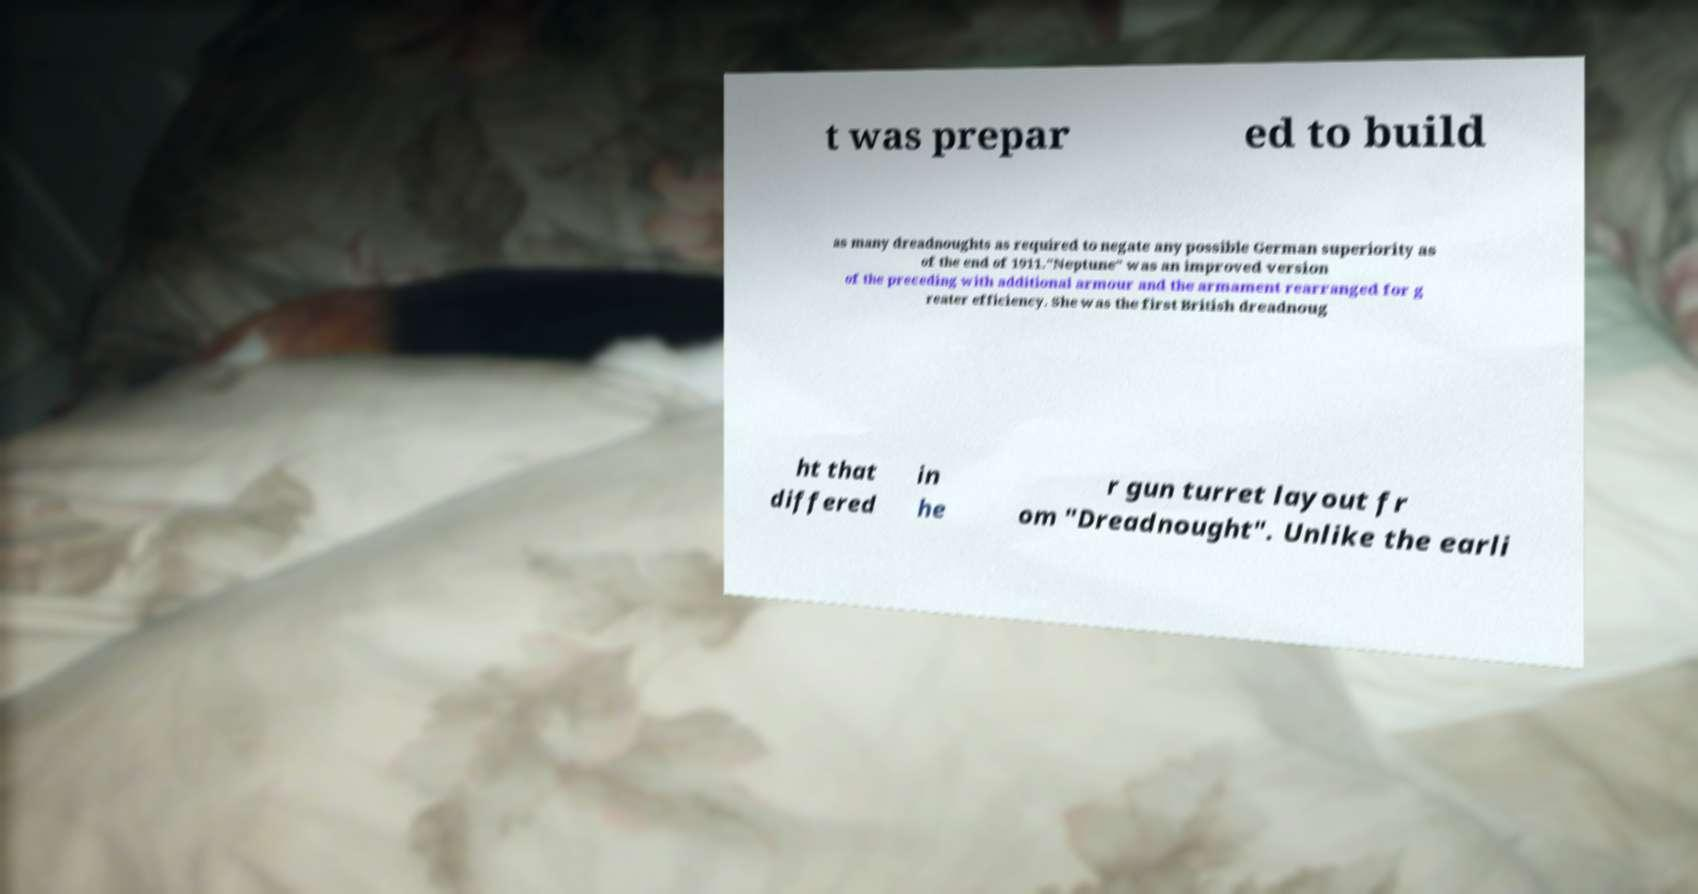Can you read and provide the text displayed in the image?This photo seems to have some interesting text. Can you extract and type it out for me? t was prepar ed to build as many dreadnoughts as required to negate any possible German superiority as of the end of 1911."Neptune" was an improved version of the preceding with additional armour and the armament rearranged for g reater efficiency. She was the first British dreadnoug ht that differed in he r gun turret layout fr om "Dreadnought". Unlike the earli 